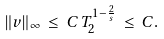<formula> <loc_0><loc_0><loc_500><loc_500>\| v \| _ { \infty } \, \leq \, C \, T _ { 2 } ^ { 1 - \frac { 2 } { s } } \, \leq \, C .</formula> 